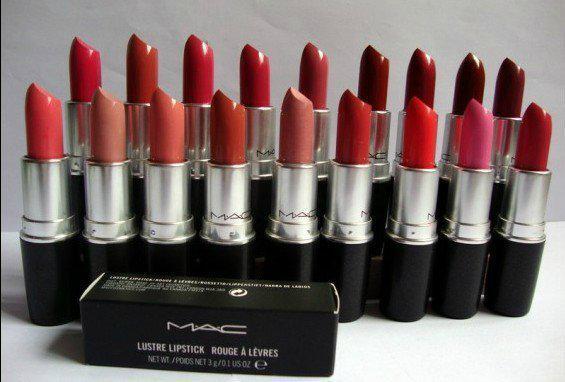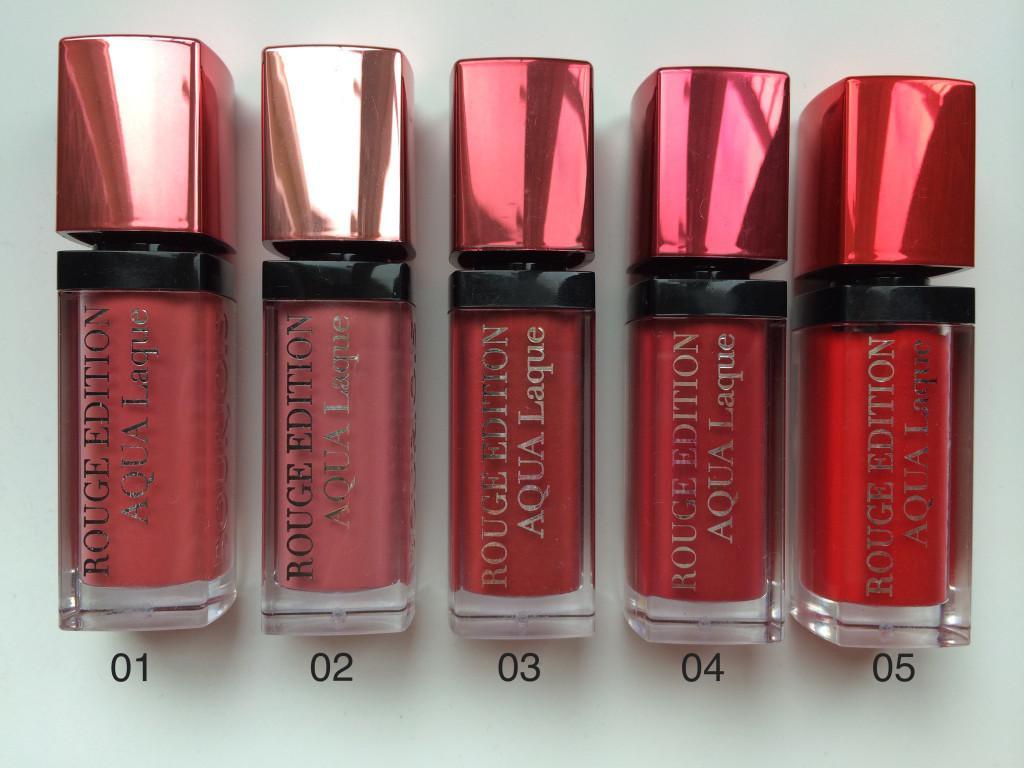The first image is the image on the left, the second image is the image on the right. Evaluate the accuracy of this statement regarding the images: "One image shows two rows of lipsticks, with a rectangular box in front of them.". Is it true? Answer yes or no. Yes. The first image is the image on the left, the second image is the image on the right. Examine the images to the left and right. Is the description "There is one box in the image on the left." accurate? Answer yes or no. Yes. 